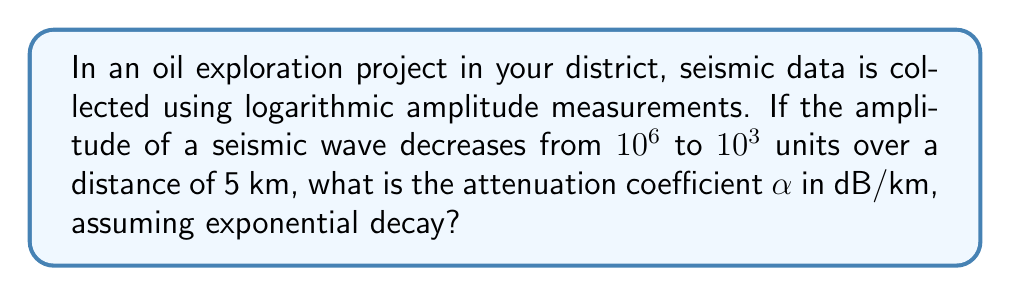Help me with this question. To solve this problem, we'll use the logarithmic decay formula and convert it to decibels (dB):

1) The general formula for exponential decay is:
   $A = A_0 e^{-\alpha x}$

2) Taking the natural logarithm of both sides:
   $\ln(A) = \ln(A_0) - \alpha x$

3) We're given:
   $A_0 = 10^6$, $A = 10^3$, and $x = 5$ km

4) Substituting these values:
   $\ln(10^3) = \ln(10^6) - 5\alpha$

5) Simplify:
   $3\ln(10) = 6\ln(10) - 5\alpha$

6) Subtract $3\ln(10)$ from both sides:
   $0 = 3\ln(10) - 5\alpha$

7) Solve for $\alpha$:
   $\alpha = \frac{3\ln(10)}{5} = 1.38$ Nepers/km

8) Convert to dB/km:
   $\alpha_{dB} = 20 \log_{10}(e) \cdot \alpha = 20 \cdot 0.434 \cdot 1.38 = 12$ dB/km

Therefore, the attenuation coefficient is approximately 12 dB/km.
Answer: 12 dB/km 